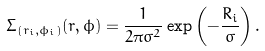Convert formula to latex. <formula><loc_0><loc_0><loc_500><loc_500>\Sigma _ { ( r _ { i } , \phi _ { i } ) } ( r , \phi ) = \frac { 1 } { 2 \pi \sigma ^ { 2 } } \exp \left ( - \frac { R _ { i } } { \sigma } \right ) .</formula> 